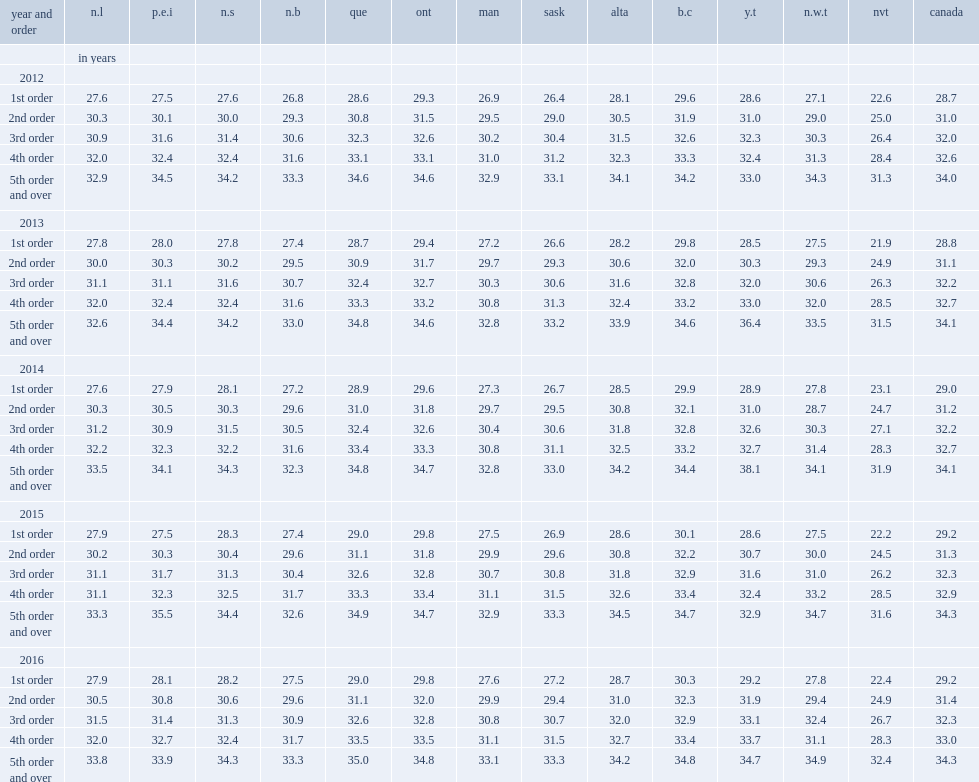Where is the highest average age of mothers at first birth in 2012? B.c. Where is the highest average age of mothers at first birth in 2016? B.c. Where is the second highest average age of mothers at first birth in 2012? Ont. Where is the second highest average age of mothers at first birth in 2016? Ont. Where is the lowest average age of mothers at first birth in 2012? Nvt. Where is the lowest average age of mothers at first birth in 2016? Nvt. 